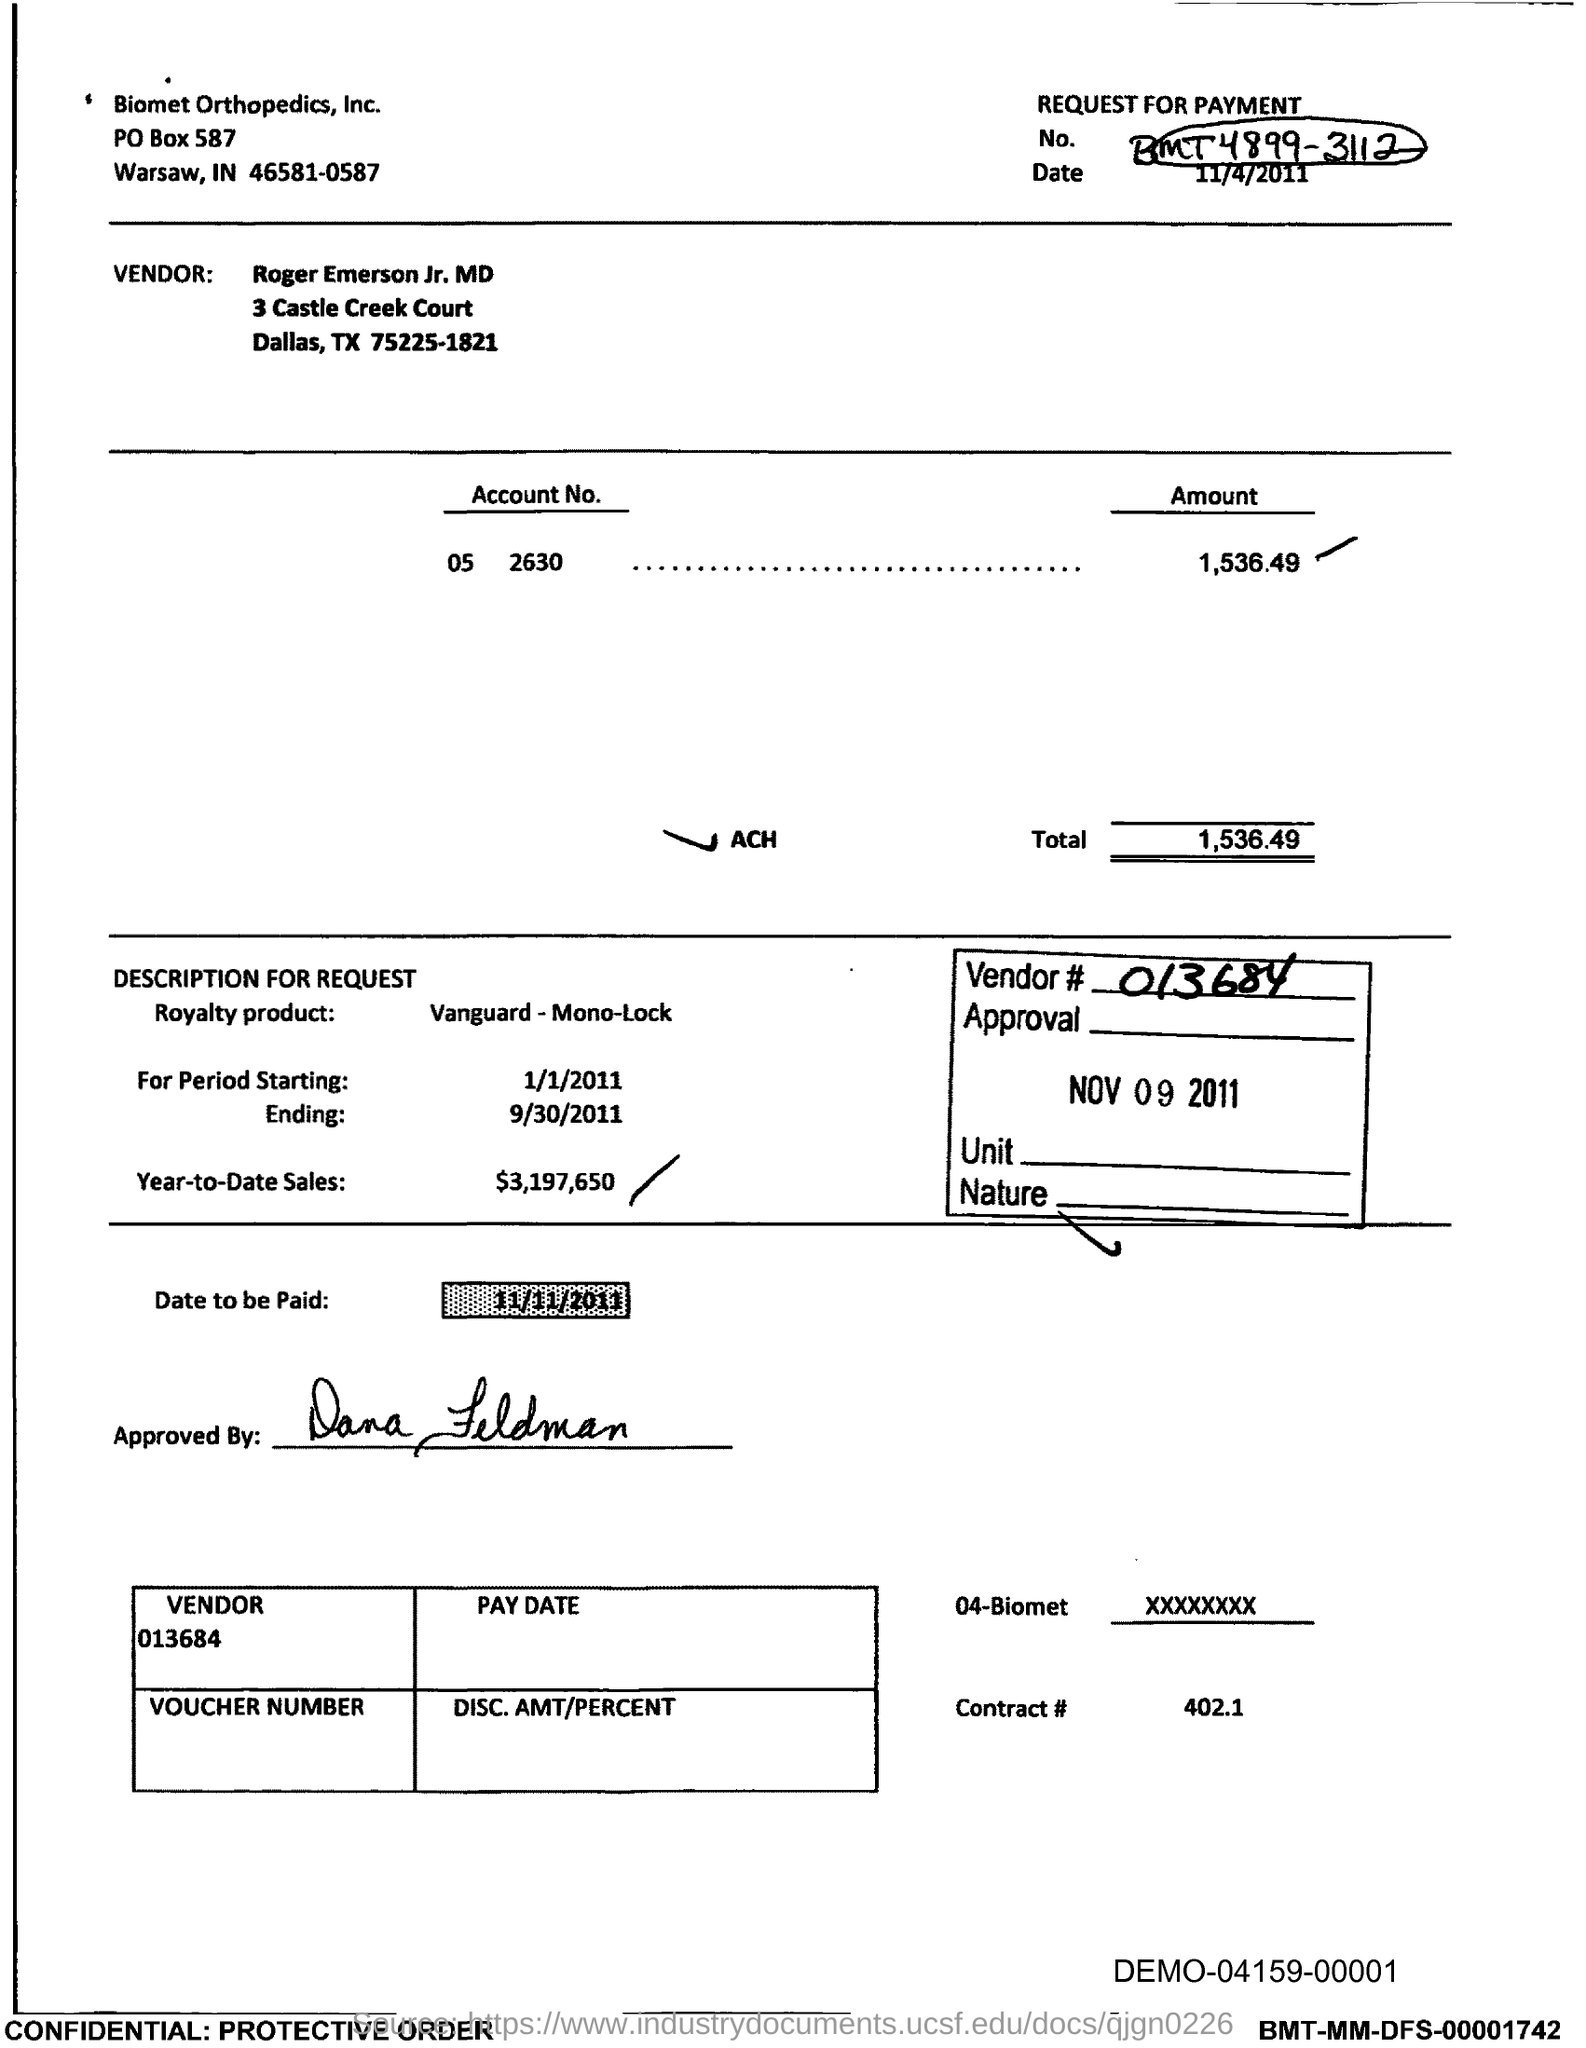What is the po box no. of biomet orthopedics, inc.?
Keep it short and to the point. 587. What is the vendor#?
Give a very brief answer. 013684. What is contract#?
Provide a short and direct response. 402.1. What is the year-to-date sales?
Keep it short and to the point. $3,197,650. What is the total?
Offer a terse response. 1,536.49. What is the date to be paid ?
Your answer should be very brief. 11/11/2011. 